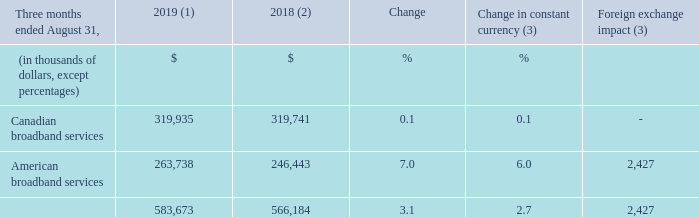REVENUE
(1) For the three-month period ended August 31, 2019, the average foreign exchange rate used for translation was 1.3222 USD/CDN.
(2) Fiscal 2018 was restated to comply with IFRS 15 and to reflect a change in accounting policy as well as to reclassify results from Cogeco Peer 1 as discontinued operations. For further details, please consult the "Accounting policies" and "Discontinued operations" sections.
(3) Fiscal 2019 actuals are translated at the average foreign exchange rate of the comparable period of fiscal 2018 which was 1.3100 USD/CDN.
Fiscal 2019 fourth-quarter revenue increased by 3.1% (2.7% in constant currency) resulting from: • growth in the American broadband services segment mainly due to strong organic growth and the FiberLight acquisition. • stable revenue in the Canadian broadband services segment mainly as a result of: ◦ rate increases; partly offset by ◦ decreases in video and telephony services customers compared to the same period of the prior year primarily due to issues resulting from the implementation of a new customer management system in the second half of fiscal 2018.
What was the exchange rate in 2019? 1.3222 usd/cdn. What was the exchange rate in 2018? 1.3100 usd/cdn. What was the increase in revenue in fourth-quarter 2019? 3.1%. What is the increase / (decrease) in the Canadian broadband services from 2018 to 2019?
Answer scale should be: thousand. 319,935 - 319,741
Answer: 194. What was the average Canadian broadband services from 2018 to 2019?
Answer scale should be: thousand. (319,935 + 319,741) / 2
Answer: 319838. What was the average American broadband services from 2018 to 2019?
Answer scale should be: thousand. (263,738 + 246,443) / 2
Answer: 255090.5. 